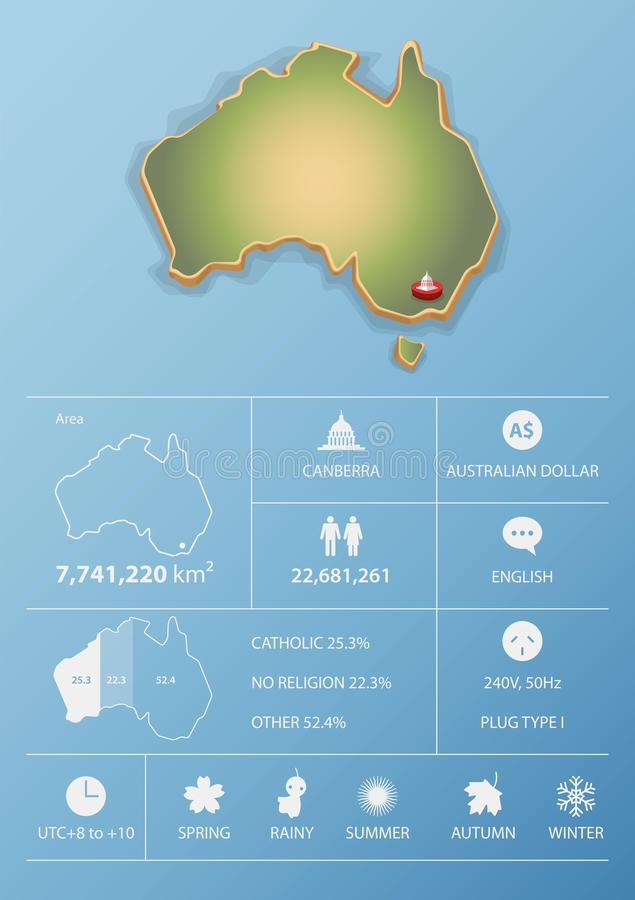Highlight a few significant elements in this photo. There are five seasons mentioned in the image. 